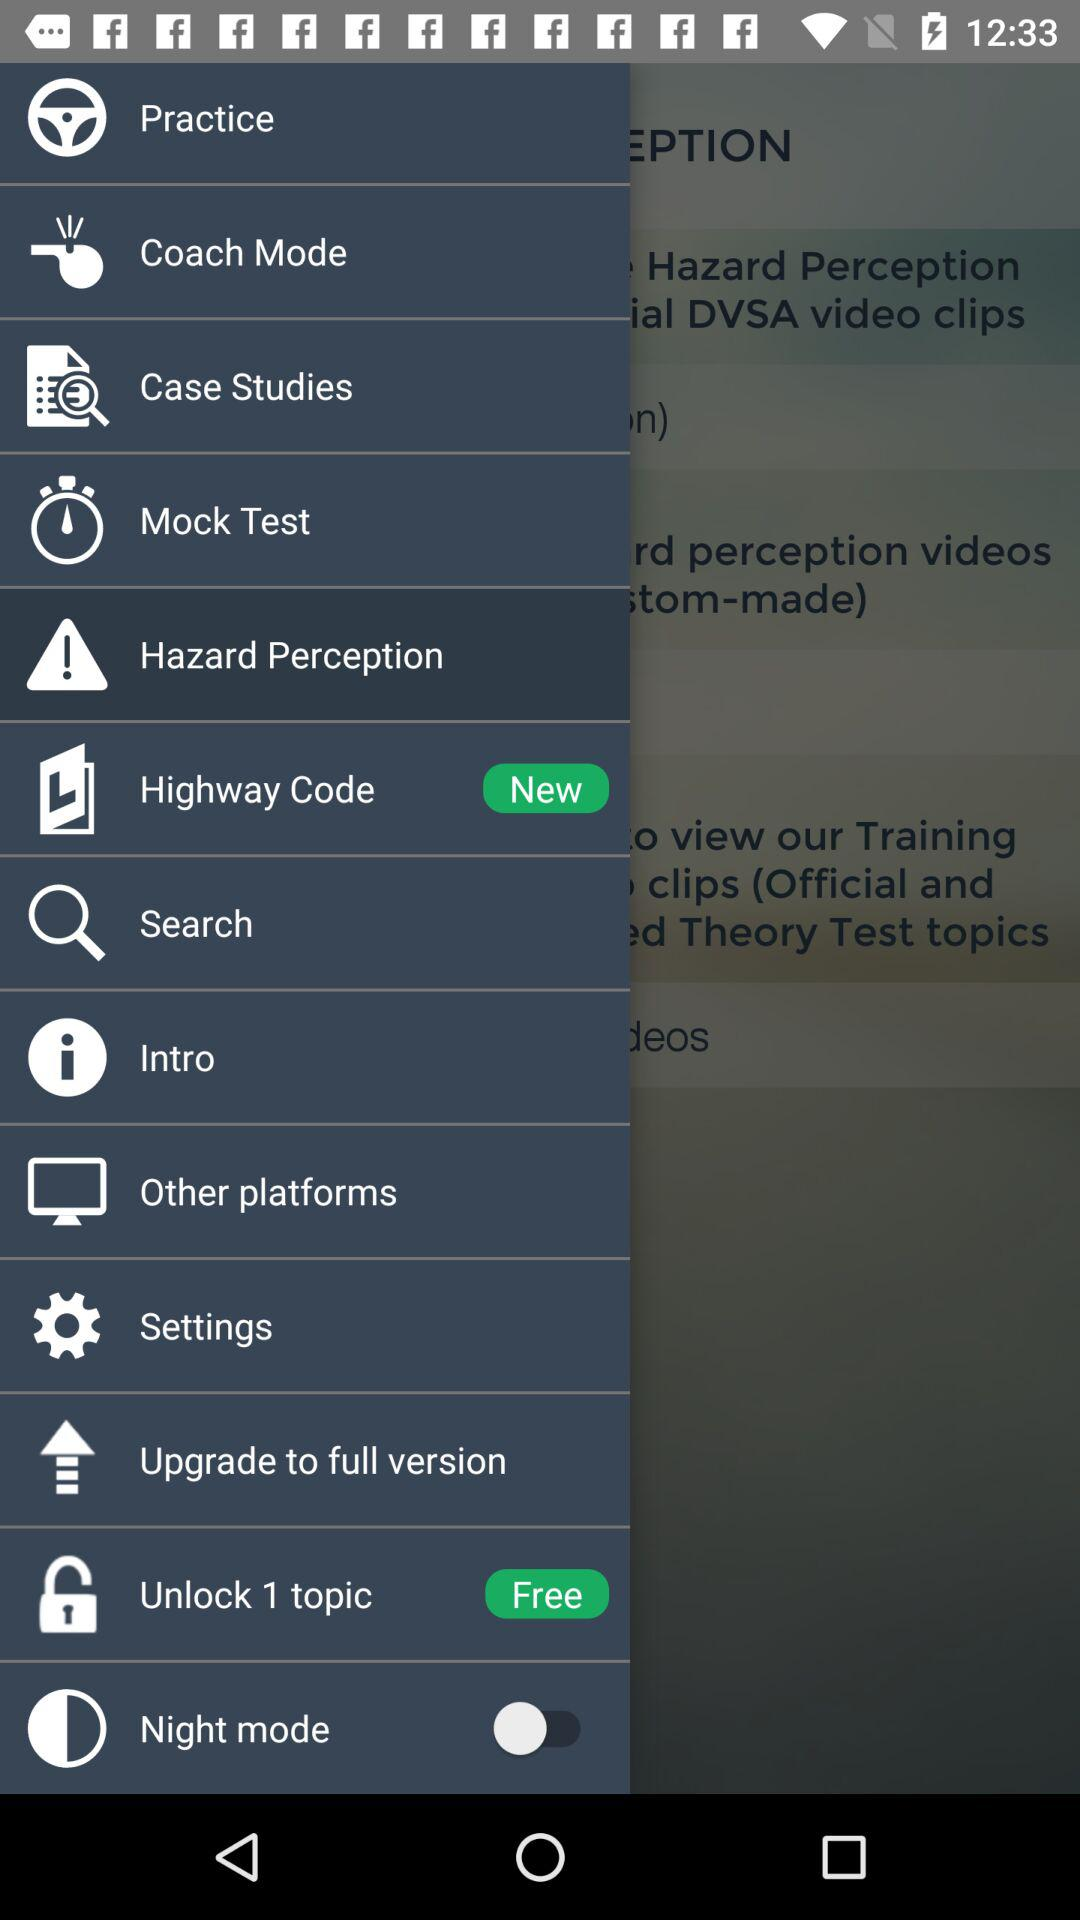Which item has been selected? The selected item is "Hazard Perception". 